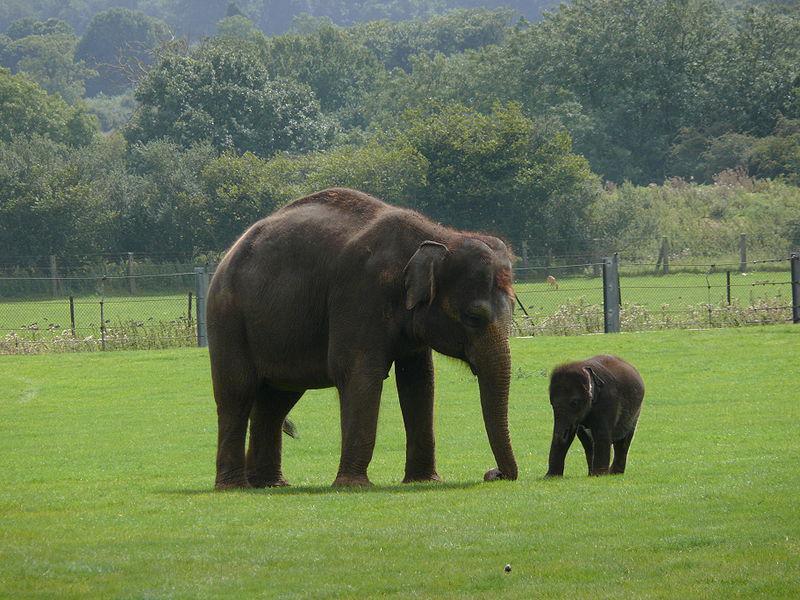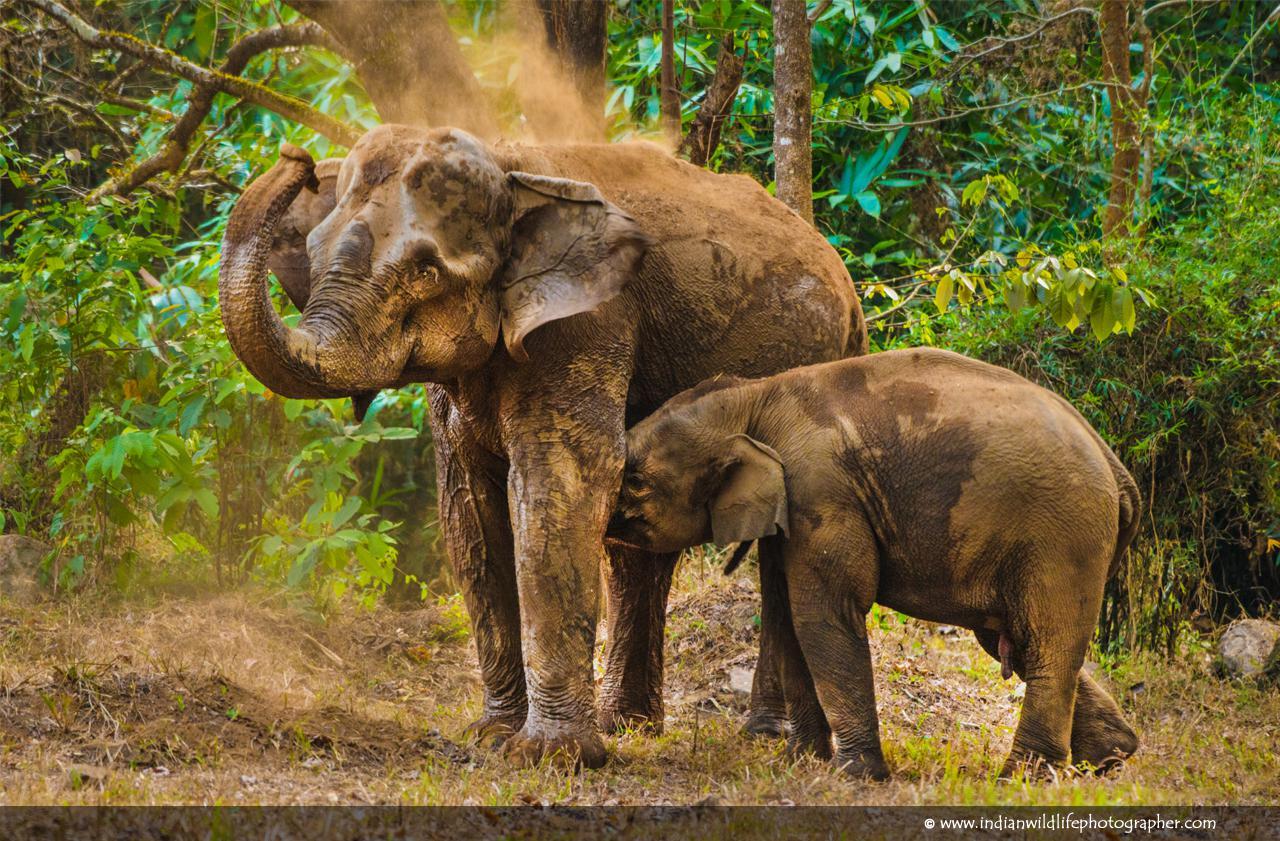The first image is the image on the left, the second image is the image on the right. Assess this claim about the two images: "An image shows one small elephant with its head poking under the legs of an adult elephant with a curled trunk.". Correct or not? Answer yes or no. Yes. The first image is the image on the left, the second image is the image on the right. For the images displayed, is the sentence "An elephant's trunk is curved up." factually correct? Answer yes or no. Yes. 